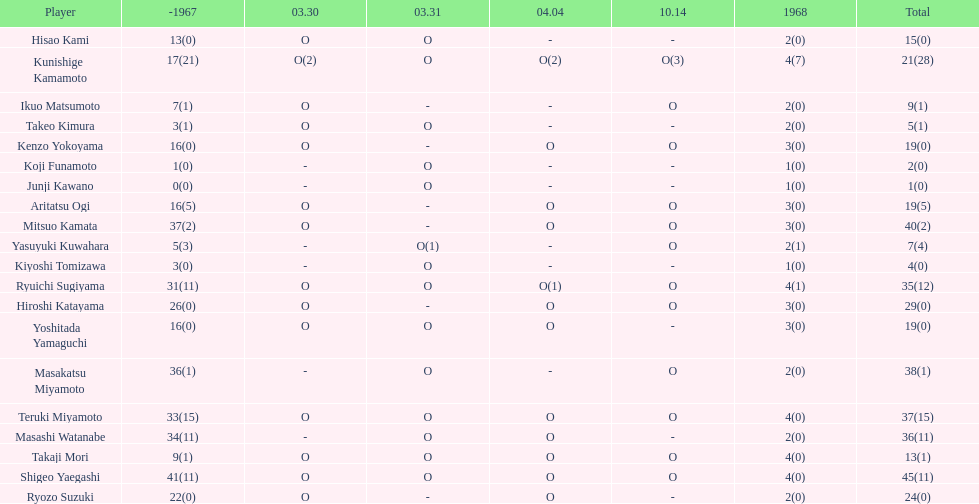Who had more points takaji mori or junji kawano? Takaji Mori. 